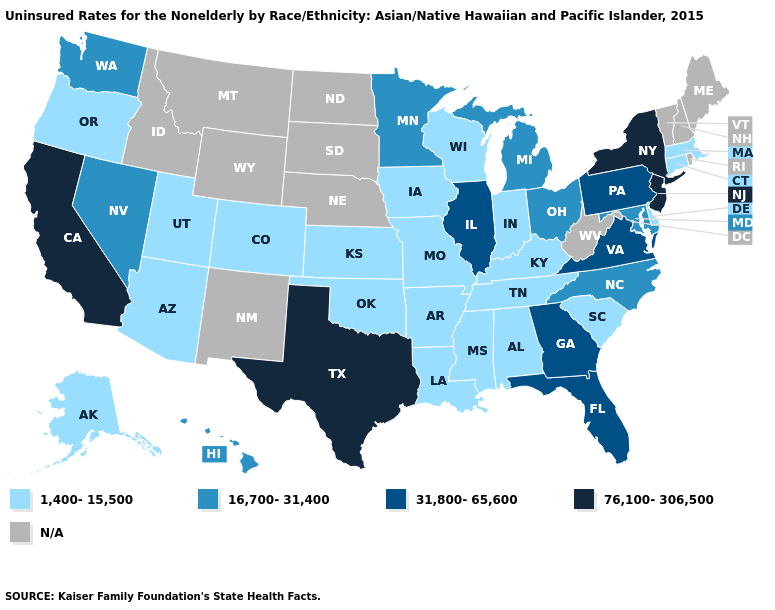Which states have the lowest value in the USA?
Be succinct. Alabama, Alaska, Arizona, Arkansas, Colorado, Connecticut, Delaware, Indiana, Iowa, Kansas, Kentucky, Louisiana, Massachusetts, Mississippi, Missouri, Oklahoma, Oregon, South Carolina, Tennessee, Utah, Wisconsin. Does the map have missing data?
Be succinct. Yes. Is the legend a continuous bar?
Keep it brief. No. What is the lowest value in states that border Rhode Island?
Quick response, please. 1,400-15,500. Name the states that have a value in the range 31,800-65,600?
Write a very short answer. Florida, Georgia, Illinois, Pennsylvania, Virginia. Does the map have missing data?
Answer briefly. Yes. Name the states that have a value in the range 1,400-15,500?
Answer briefly. Alabama, Alaska, Arizona, Arkansas, Colorado, Connecticut, Delaware, Indiana, Iowa, Kansas, Kentucky, Louisiana, Massachusetts, Mississippi, Missouri, Oklahoma, Oregon, South Carolina, Tennessee, Utah, Wisconsin. What is the highest value in the West ?
Answer briefly. 76,100-306,500. What is the lowest value in states that border Nebraska?
Short answer required. 1,400-15,500. Does Kentucky have the highest value in the USA?
Answer briefly. No. Does New York have the lowest value in the Northeast?
Short answer required. No. What is the value of Utah?
Quick response, please. 1,400-15,500. Name the states that have a value in the range N/A?
Be succinct. Idaho, Maine, Montana, Nebraska, New Hampshire, New Mexico, North Dakota, Rhode Island, South Dakota, Vermont, West Virginia, Wyoming. 